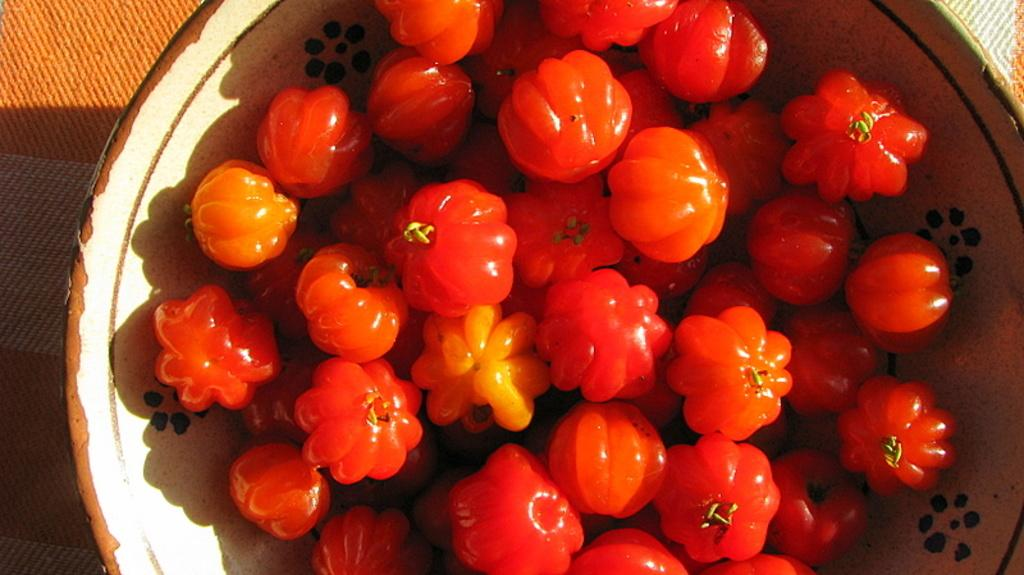What type of food can be seen in the image? There are fruits in the image. How are the fruits arranged in the image? The fruits are in a bowl. What is the bowl resting on in the image? The bowl is on a cloth. What type of credit card is visible in the image? There is no credit card present in the image; it features fruits in a bowl on a cloth. 